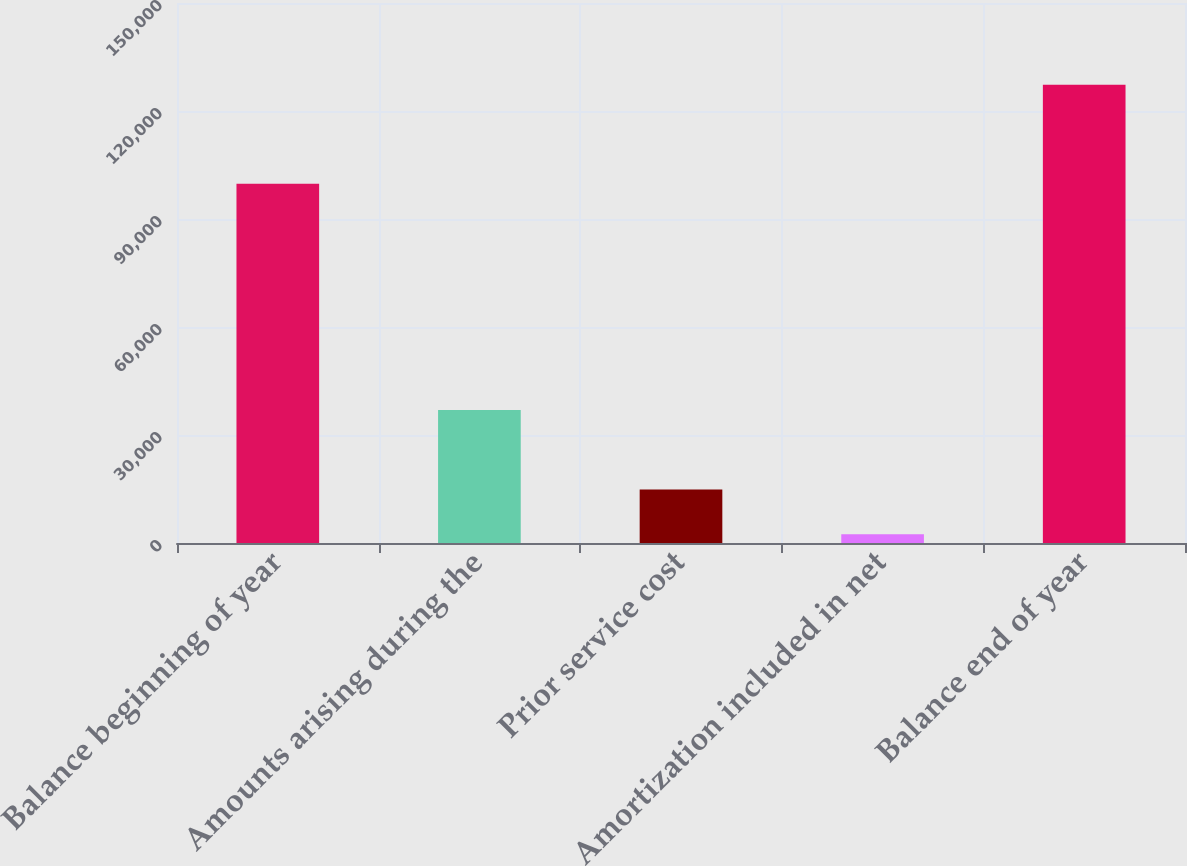<chart> <loc_0><loc_0><loc_500><loc_500><bar_chart><fcel>Balance beginning of year<fcel>Amounts arising during the<fcel>Prior service cost<fcel>Amortization included in net<fcel>Balance end of year<nl><fcel>99813<fcel>36934<fcel>14891.9<fcel>2403<fcel>127292<nl></chart> 